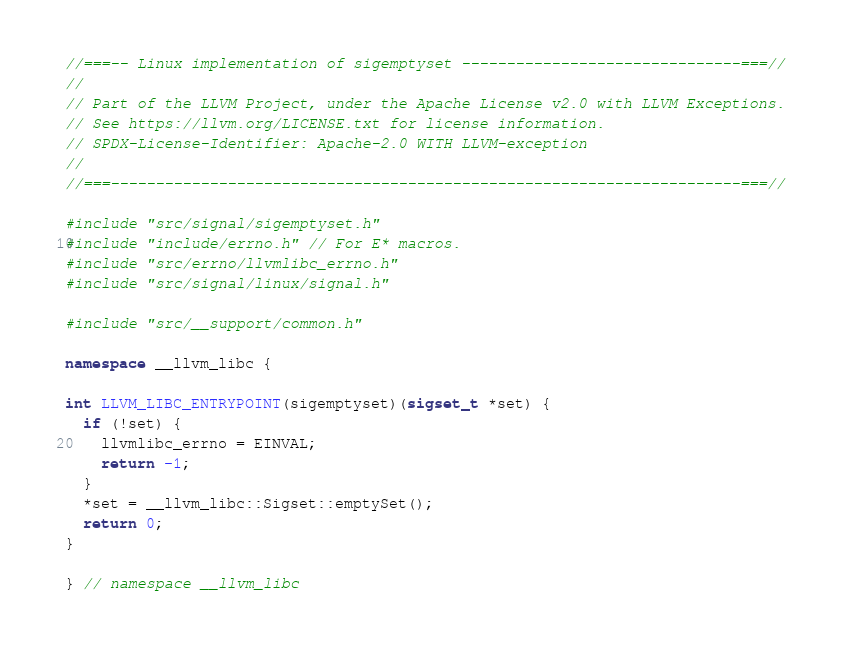<code> <loc_0><loc_0><loc_500><loc_500><_C++_>//===-- Linux implementation of sigemptyset -------------------------------===//
//
// Part of the LLVM Project, under the Apache License v2.0 with LLVM Exceptions.
// See https://llvm.org/LICENSE.txt for license information.
// SPDX-License-Identifier: Apache-2.0 WITH LLVM-exception
//
//===----------------------------------------------------------------------===//

#include "src/signal/sigemptyset.h"
#include "include/errno.h" // For E* macros.
#include "src/errno/llvmlibc_errno.h"
#include "src/signal/linux/signal.h"

#include "src/__support/common.h"

namespace __llvm_libc {

int LLVM_LIBC_ENTRYPOINT(sigemptyset)(sigset_t *set) {
  if (!set) {
    llvmlibc_errno = EINVAL;
    return -1;
  }
  *set = __llvm_libc::Sigset::emptySet();
  return 0;
}

} // namespace __llvm_libc
</code> 